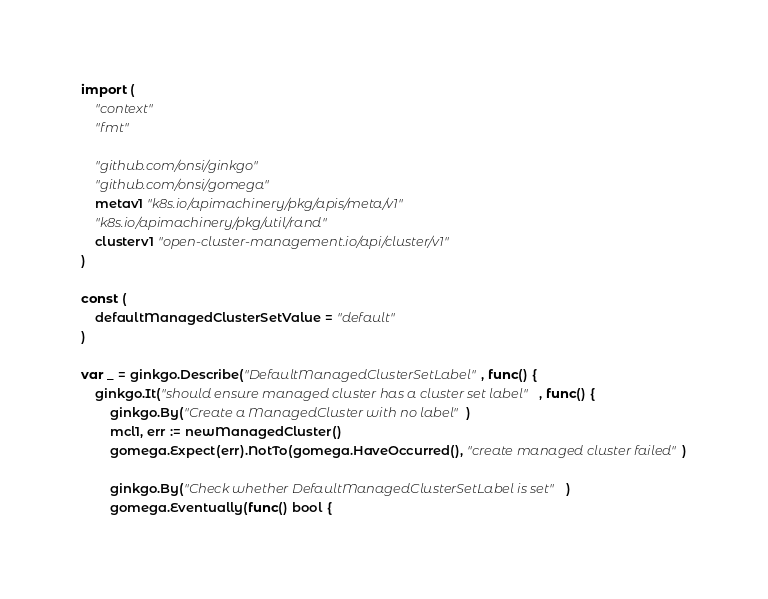<code> <loc_0><loc_0><loc_500><loc_500><_Go_>import (
	"context"
	"fmt"

	"github.com/onsi/ginkgo"
	"github.com/onsi/gomega"
	metav1 "k8s.io/apimachinery/pkg/apis/meta/v1"
	"k8s.io/apimachinery/pkg/util/rand"
	clusterv1 "open-cluster-management.io/api/cluster/v1"
)

const (
	defaultManagedClusterSetValue = "default"
)

var _ = ginkgo.Describe("DefaultManagedClusterSetLabel", func() {
	ginkgo.It("should ensure managed cluster has a cluster set label", func() {
		ginkgo.By("Create a ManagedCluster with no label")
		mcl1, err := newManagedCluster()
		gomega.Expect(err).NotTo(gomega.HaveOccurred(), "create managed cluster failed")

		ginkgo.By("Check whether DefaultManagedClusterSetLabel is set")
		gomega.Eventually(func() bool {</code> 